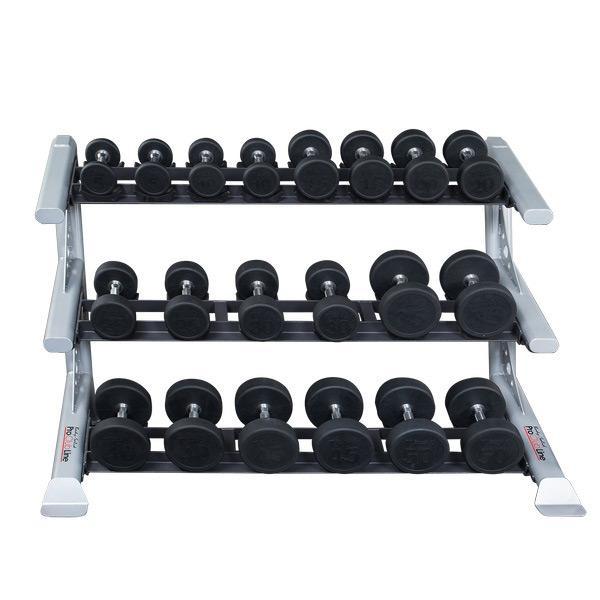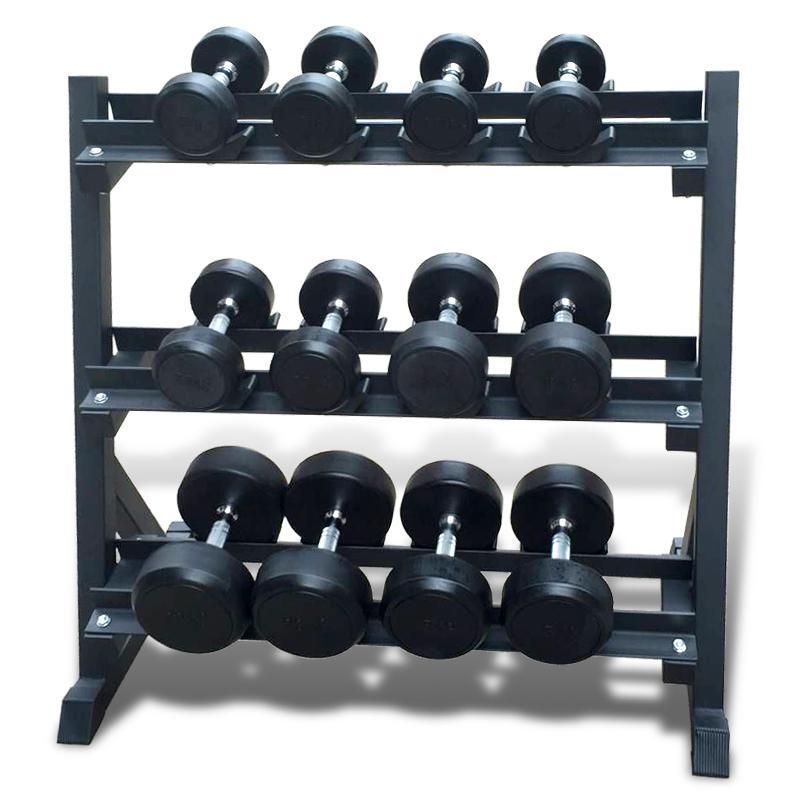The first image is the image on the left, the second image is the image on the right. Examine the images to the left and right. Is the description "The weights sitting in the rack in the image on the left are round in shape." accurate? Answer yes or no. Yes. The first image is the image on the left, the second image is the image on the right. Given the left and right images, does the statement "Left and right racks hold three rows of dumbbells, and dumbbells have the same end shapes in both images." hold true? Answer yes or no. Yes. 